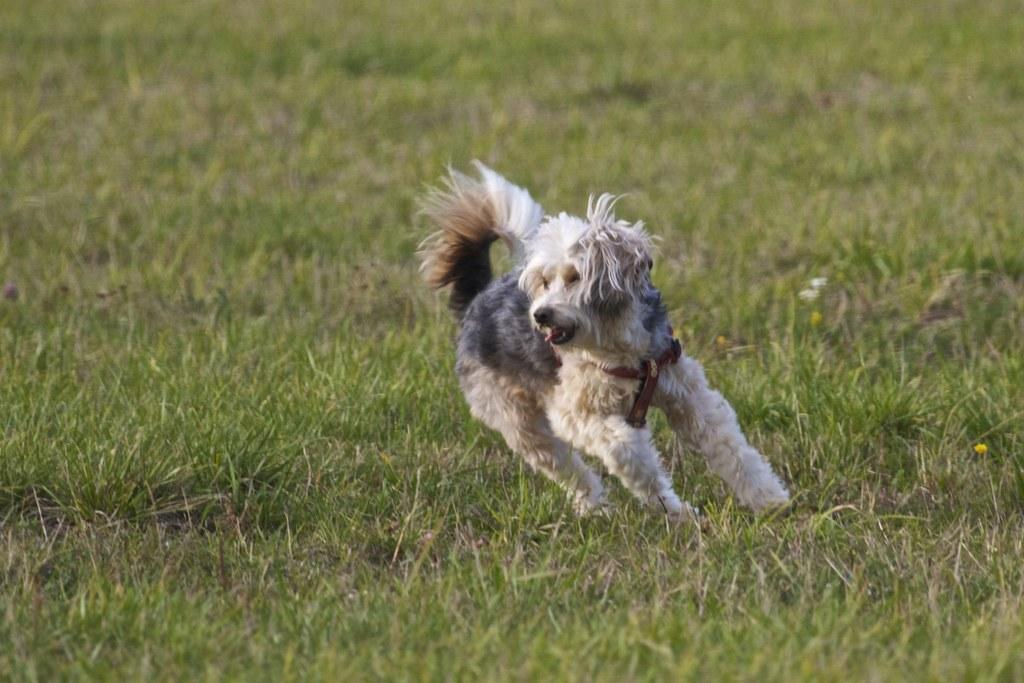What type of animal is in the image? There is a dog in the image. What colors can be seen on the dog? The dog is black and white in color. What is the dog doing in the image? The dog is standing. What type of terrain is visible in the image? There is grass on the ground in the image. What accessory is the dog wearing? The dog is wearing a brown-colored belt. Can you see any mountains in the background of the image? There are no mountains visible in the image; it features a dog standing on grass. Is there a shop nearby where the dog can buy treats? There is no shop present in the image, and the location of any nearby shops cannot be determined from the image. 